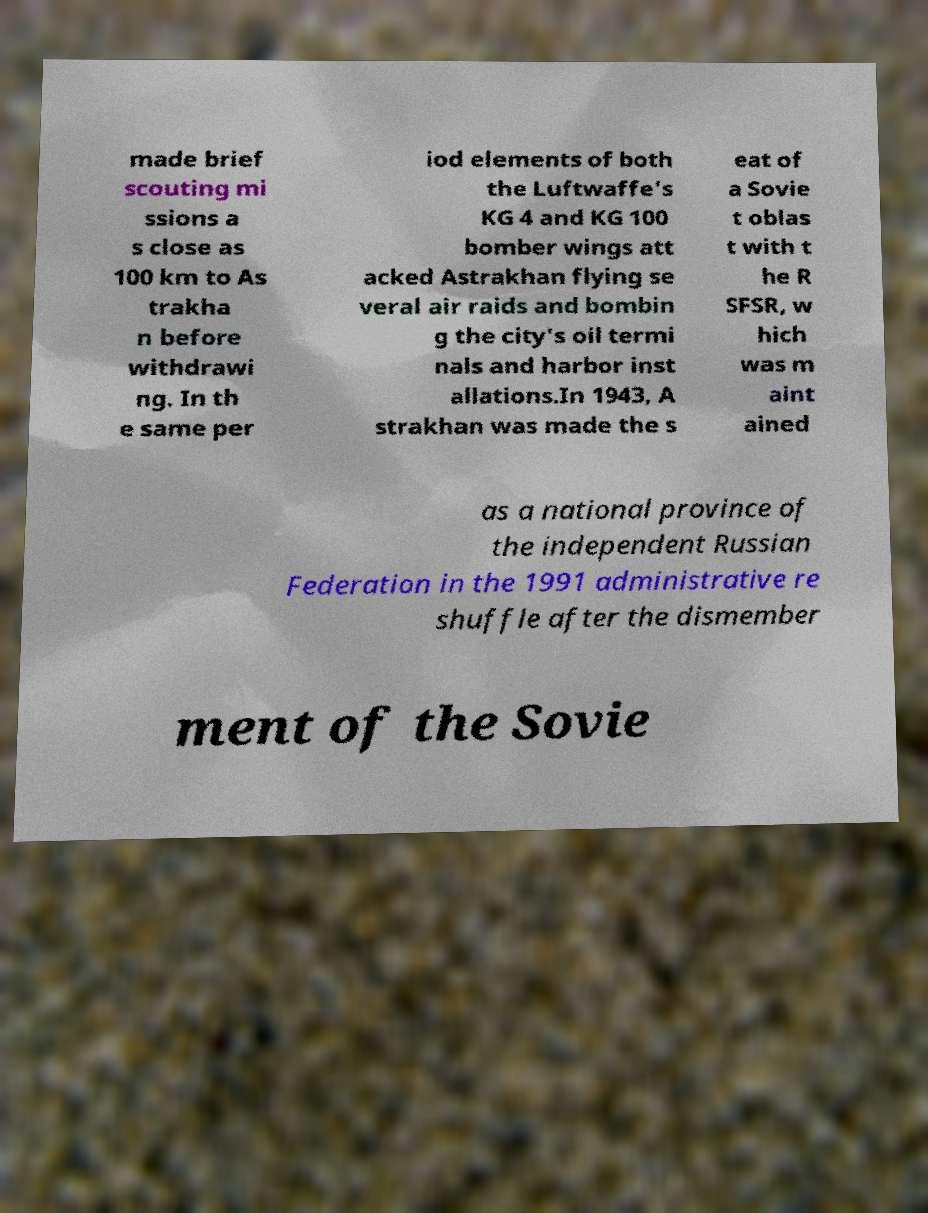Can you read and provide the text displayed in the image?This photo seems to have some interesting text. Can you extract and type it out for me? made brief scouting mi ssions a s close as 100 km to As trakha n before withdrawi ng. In th e same per iod elements of both the Luftwaffe's KG 4 and KG 100 bomber wings att acked Astrakhan flying se veral air raids and bombin g the city's oil termi nals and harbor inst allations.In 1943, A strakhan was made the s eat of a Sovie t oblas t with t he R SFSR, w hich was m aint ained as a national province of the independent Russian Federation in the 1991 administrative re shuffle after the dismember ment of the Sovie 